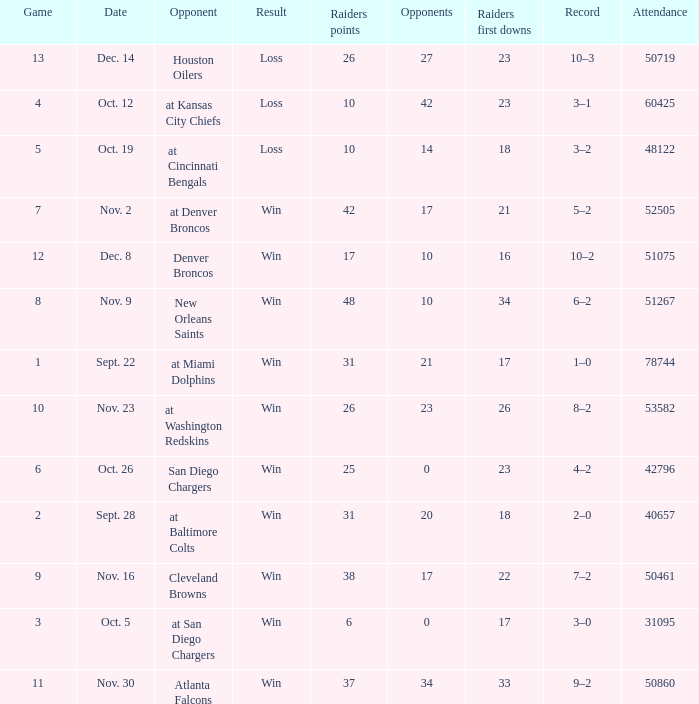How many different counts of the Raiders first downs are there for the game number 9? 1.0. 